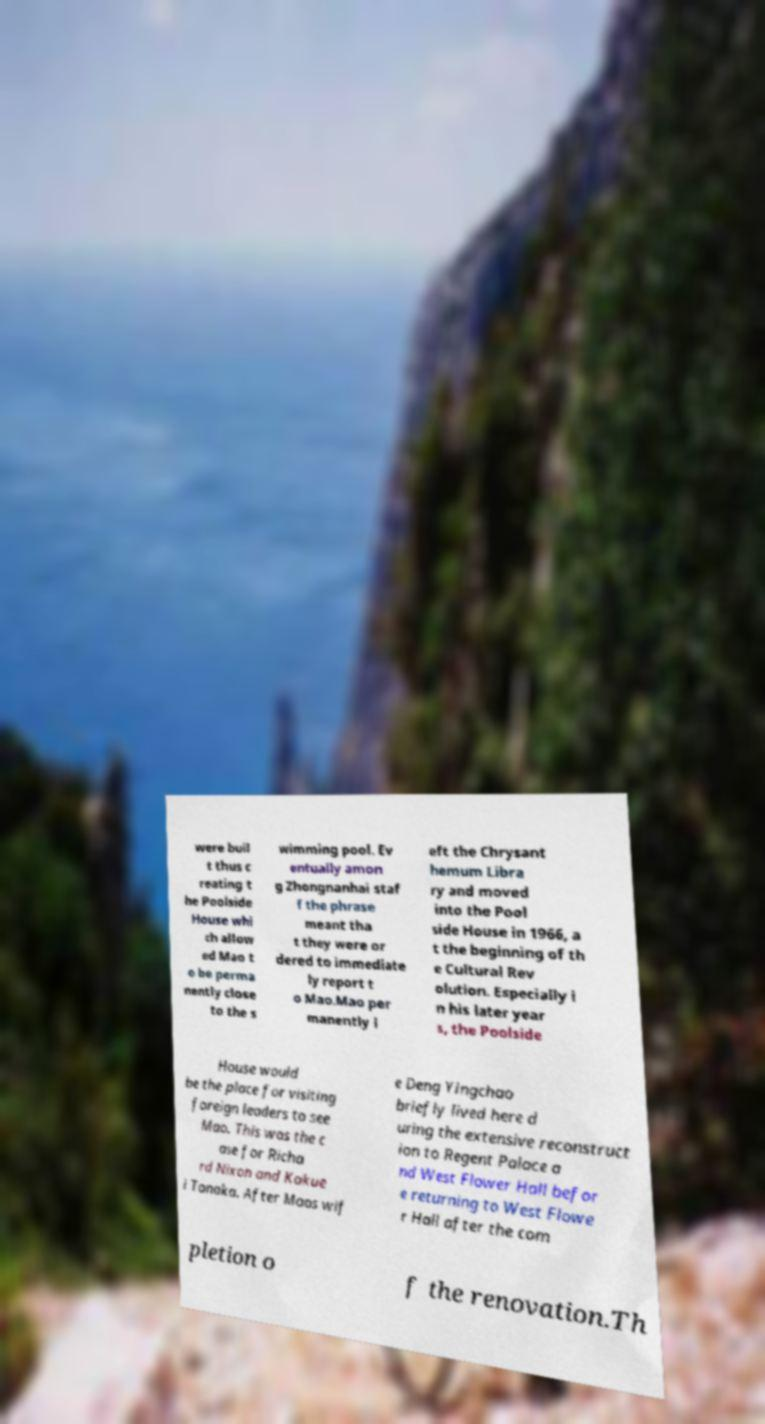I need the written content from this picture converted into text. Can you do that? were buil t thus c reating t he Poolside House whi ch allow ed Mao t o be perma nently close to the s wimming pool. Ev entually amon g Zhongnanhai staf f the phrase meant tha t they were or dered to immediate ly report t o Mao.Mao per manently l eft the Chrysant hemum Libra ry and moved into the Pool side House in 1966, a t the beginning of th e Cultural Rev olution. Especially i n his later year s, the Poolside House would be the place for visiting foreign leaders to see Mao. This was the c ase for Richa rd Nixon and Kakue i Tanaka. After Maos wif e Deng Yingchao briefly lived here d uring the extensive reconstruct ion to Regent Palace a nd West Flower Hall befor e returning to West Flowe r Hall after the com pletion o f the renovation.Th 